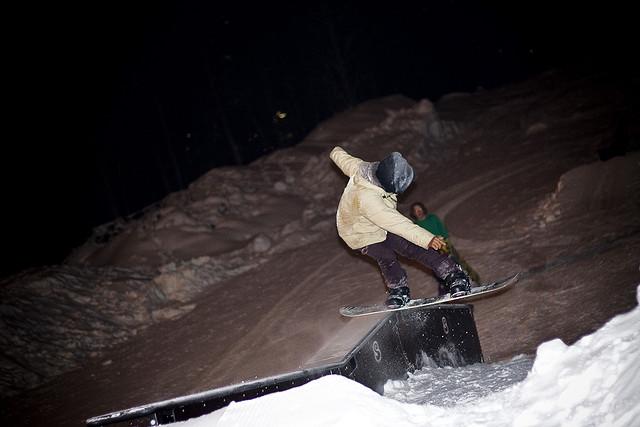Is the person wearing gloves?
Short answer required. No. Does this person have on a coat?
Concise answer only. Yes. How many colors are in the boy's shirt?
Give a very brief answer. 1. Is this activity taking place at night?
Keep it brief. Yes. 